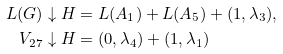Convert formula to latex. <formula><loc_0><loc_0><loc_500><loc_500>L ( G ) \downarrow H & = L ( A _ { 1 } ) + L ( A _ { 5 } ) + ( 1 , \lambda _ { 3 } ) , \\ V _ { 2 7 } \downarrow H & = ( 0 , \lambda _ { 4 } ) + ( 1 , \lambda _ { 1 } )</formula> 